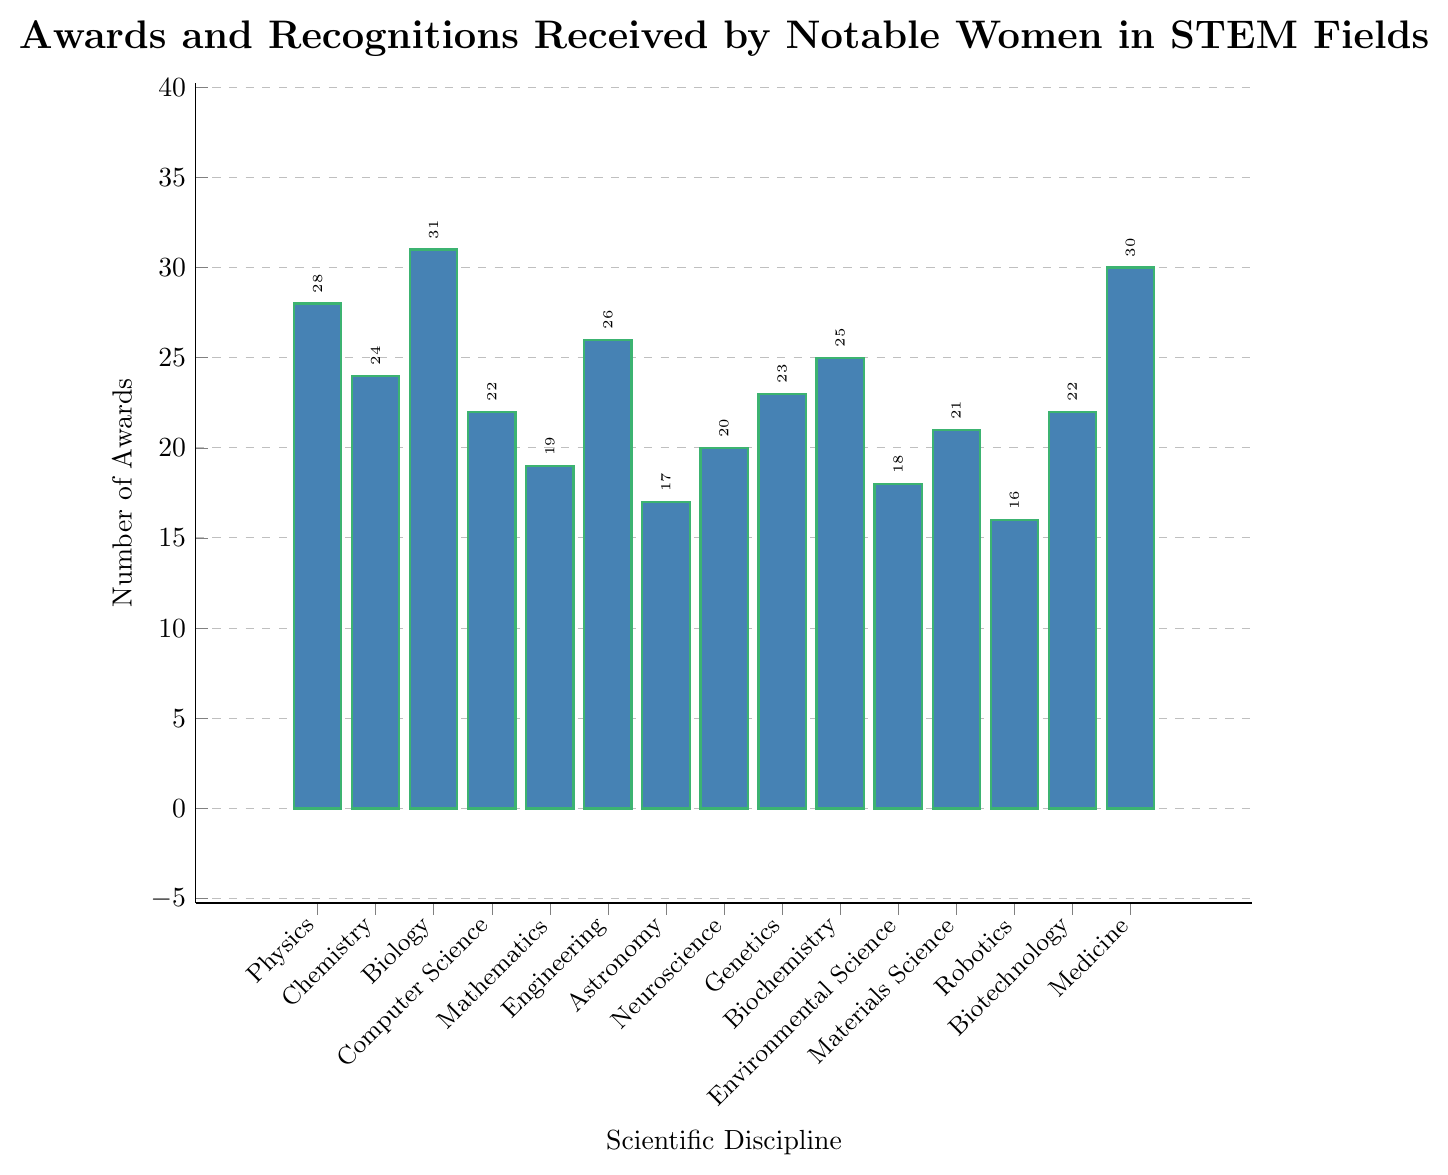What's the total number of awards received in Biology and Medicine? To find the total number of awards in Biology and Medicine, sum the awards for these two disciplines. Biology has 31 awards and Medicine has 30 awards. So, 31 + 30 = 61.
Answer: 61 Which scientific discipline has received the highest number of awards? By observing the heights of the bars, identify the bar that represents the highest number. Biology has the tallest bar with 31 awards.
Answer: Biology How many more awards were given in Engineering compared to Robotics? To find the difference, subtract the number of awards in Robotics from the number in Engineering. Engineering has 26 awards and Robotics has 16. So, 26 - 16 = 10.
Answer: 10 What's the average number of awards received across all disciplines? To calculate the average, sum the number of awards for all disciplines and then divide by the number of disciplines (15). The sum is 28+24+31+22+19+26+17+20+23+25+18+21+16+22+30 = 342. The average is 342 / 15 = 22.8.
Answer: 22.8 Are there more awards in Chemistry or Computer Science, and by how many? Compare the number of awards in Chemistry and Computer Science. Chemistry has 24 awards, and Computer Science has 22. The difference is 24 - 22 = 2.
Answer: Chemistry, 2 What is the range of awards across the disciplines? Find the maximum and minimum number of awards. The maximum is 31 (Biology) and the minimum is 16 (Robotics). The range is 31 - 16 = 15.
Answer: 15 Which disciplines have an equal number of awards? Identifiy any disciplines with the same bar height. Biotechnology and Computer Science both have 22 awards.
Answer: Biotechnology and Computer Science What is the median number of awards in the dataset? First, list the number of awards in ascending order: 16, 17, 18, 19, 20, 21, 22, 22, 23, 24, 25, 26, 28, 30, 31. The median is the middle value. Since there are 15 disciplines, the median is the 8th value, which is 22.
Answer: 22 What's the difference in the number of awards between the discipline with the highest awards and the discipline with the lowest? Identify the highest and lowest values: Biology has 31, and Robotics has 16. The difference is 31 - 16 = 15.
Answer: 15 How does the number of awards in Materials Science compare to that in Mathematics? Compare the two numbers directly. Materials Science has 21 awards and Mathematics has 19. Materials Science has 2 more awards than Mathematics.
Answer: Materials Science, 2 